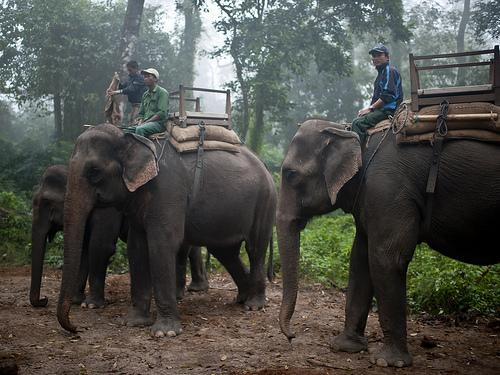In an imaginative way, describe the atmosphere of the image. A captivating jungle adventure unfolds as three majestic elephants and their vibrant riders navigate their leafy surroundings, adorned with colorful accessories and riding gear. What are the riders holding or wearing and where are they positioned on the elephants? The riders, wearing caps and colorful clothing, are sitting or standing on the elephants' backs, holding items like blankets and rugs in their hands. Describe the footwear of the elephants and where they stand in the picture. The elephants, standing on soil, have distinctive toes and toenails, while one has three visible toenails. Describe the interaction between the men and the elephants in the image. The men are riding atop the elephants, utilizing seats and harnesses, while holding various items such as blankets and wearing different clothing items, including caps and green pants. List three accessories attached to the elephants and mention their colors. There is a brown sack on an elephant, a hathi howdah with pillows in the back, and straps holding the howdah on the back of another elephant. Mention the sizes of the elephants and the color of the smallest one's ear. There are three elephants of varying sizes, with one being smaller than the others and having a pinkish hue on its ear. Provide a brief overview of the scene captured in the image. Three elephants and their riders are gathered in a jungle setting, with a man on each elephant's back and various accessories such as straps, seats, and bags. What are the men wearing on their heads while riding the elephants? The men are wearing baseball caps, with one man wearing a tan cap and another wearing a navy blue cap. Mention the most notable aspect of the elephants and something interesting about their appearance. The elephants have large ears, long trunks, and are of various sizes, with one being notably smaller than the others, featuring pink on its ear. Describe the main focus of the image using a poetic style. In a verdant jungle, three stately elephants stand abreast, their riders perched above, a symphony of nature and human connection painted in earthy hues and vibrant attire. 